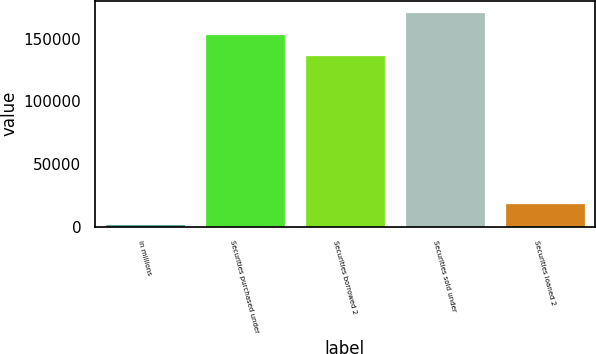<chart> <loc_0><loc_0><loc_500><loc_500><bar_chart><fcel>in millions<fcel>Securities purchased under<fcel>Securities borrowed 2<fcel>Securities sold under<fcel>Securities loaned 2<nl><fcel>2012<fcel>153872<fcel>136893<fcel>171807<fcel>18991.5<nl></chart> 